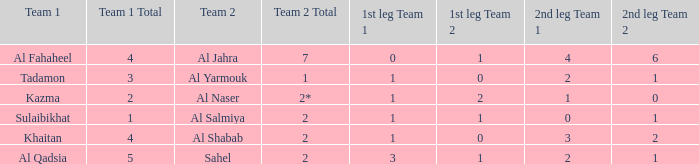What is the name of Team 2 with a 2nd leg of 4-6? Al Jahra. 